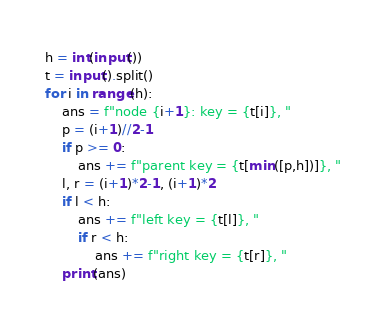Convert code to text. <code><loc_0><loc_0><loc_500><loc_500><_Python_>h = int(input())
t = input().split()
for i in range(h):
    ans = f"node {i+1}: key = {t[i]}, "
    p = (i+1)//2-1
    if p >= 0:
        ans += f"parent key = {t[min([p,h])]}, "
    l, r = (i+1)*2-1, (i+1)*2
    if l < h:
        ans += f"left key = {t[l]}, "
        if r < h:
            ans += f"right key = {t[r]}, "
    print(ans)

</code> 